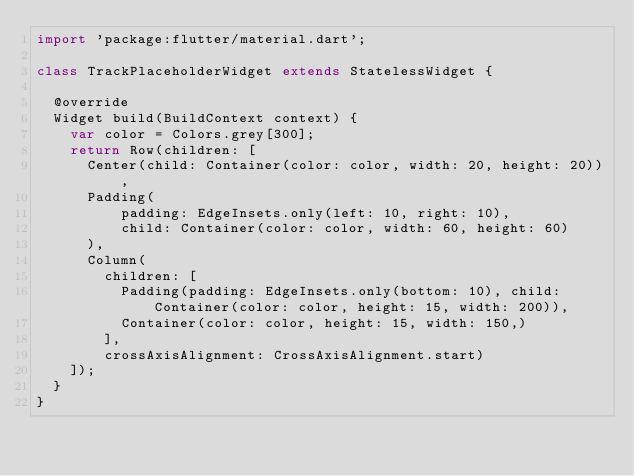Convert code to text. <code><loc_0><loc_0><loc_500><loc_500><_Dart_>import 'package:flutter/material.dart';

class TrackPlaceholderWidget extends StatelessWidget {

  @override
  Widget build(BuildContext context) {
    var color = Colors.grey[300];
    return Row(children: [
      Center(child: Container(color: color, width: 20, height: 20)),
      Padding(
          padding: EdgeInsets.only(left: 10, right: 10),
          child: Container(color: color, width: 60, height: 60)
      ),
      Column(
        children: [
          Padding(padding: EdgeInsets.only(bottom: 10), child: Container(color: color, height: 15, width: 200)),
          Container(color: color, height: 15, width: 150,)
        ],
        crossAxisAlignment: CrossAxisAlignment.start)
    ]);
  }
}</code> 